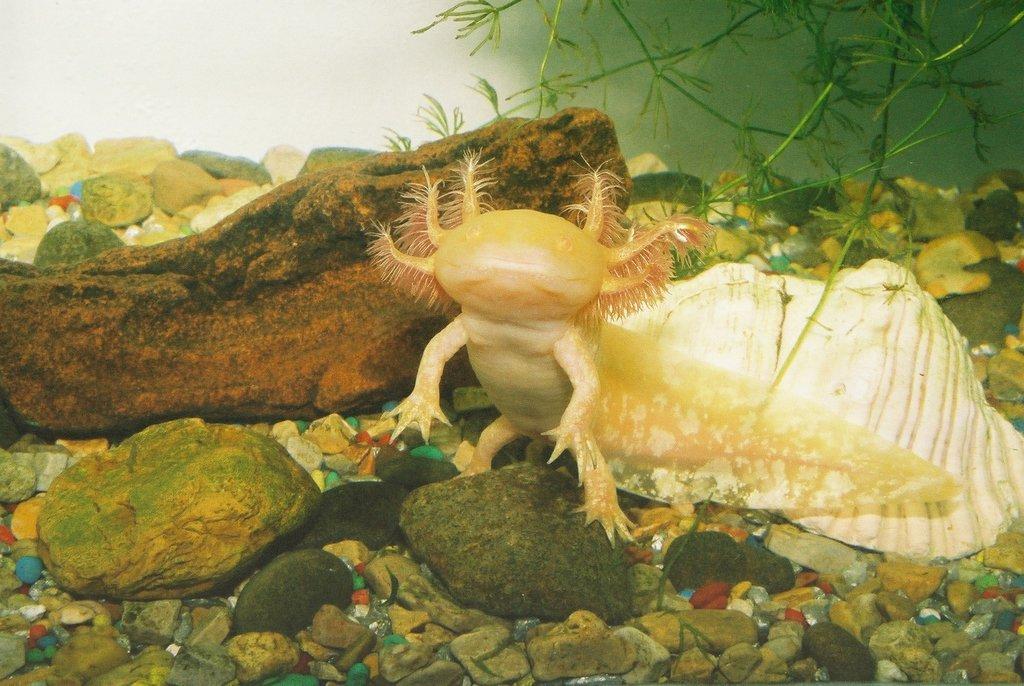Please provide a concise description of this image. This is an inside view of the water. In this image I can see few stones, shell, a plant and some other marine species. 